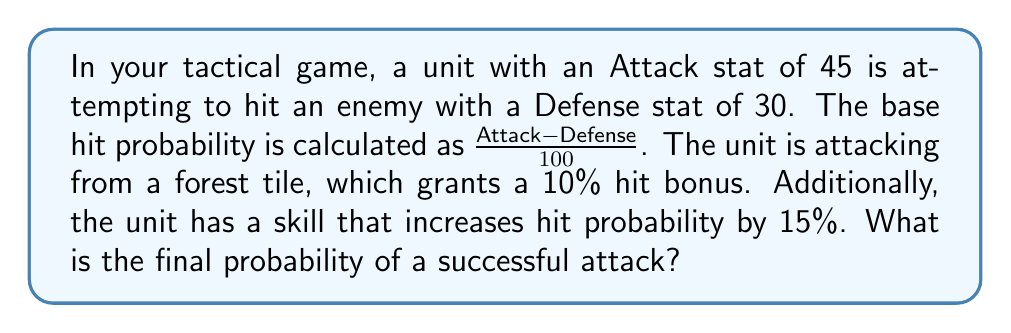Can you solve this math problem? Let's break this down step-by-step:

1) First, calculate the base hit probability:
   $$ Base\_Prob = \frac{Attack - Defense}{100} = \frac{45 - 30}{100} = \frac{15}{100} = 0.15 $$

2) The forest tile grants a 10% (or 0.10) hit bonus. This is additive to the base probability:
   $$ Terrain\_Adjusted\_Prob = Base\_Prob + 0.10 = 0.15 + 0.10 = 0.25 $$

3) The unit's skill adds another 15% (or 0.15) hit probability. This is also additive:
   $$ Final\_Prob = Terrain\_Adjusted\_Prob + 0.15 = 0.25 + 0.15 = 0.40 $$

4) Convert the final probability to a percentage:
   $$ Final\_Percentage = Final\_Prob \times 100\% = 0.40 \times 100\% = 40\% $$

Note: In probability calculations, we typically cap the final probability at 1.0 (or 100%). In this case, our result is below that threshold, so no capping is necessary.
Answer: The final probability of a successful attack is 40%. 